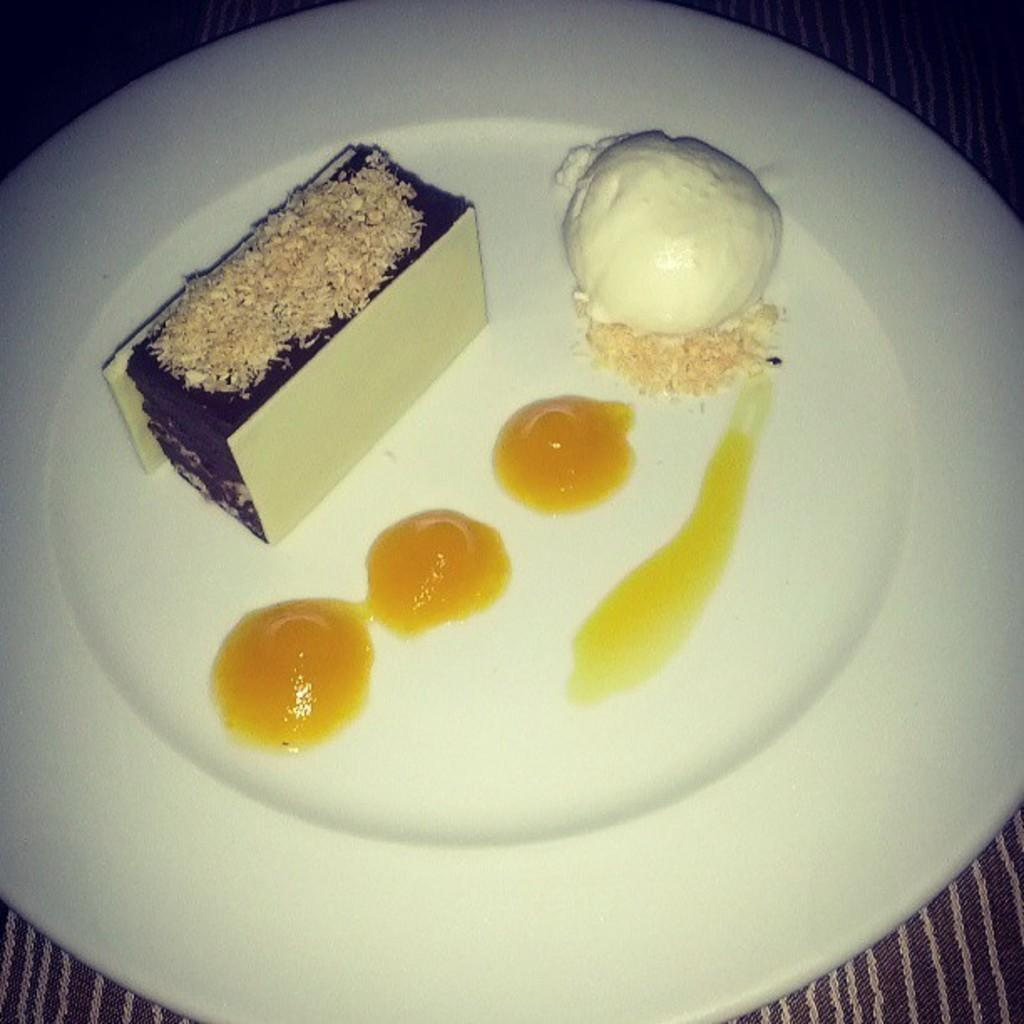What is on the plate that is visible in the image? There is a plate with dessert in the image. What type of sauce is on the plate? There is sauce on the plate. What other dessert item is on the plate? There is ice cream on the plate. Where is the plate located in the image? The plate is placed on a table. How many pieces of paper are on the plate in the image? There are no pieces of paper present on the plate in the image. 